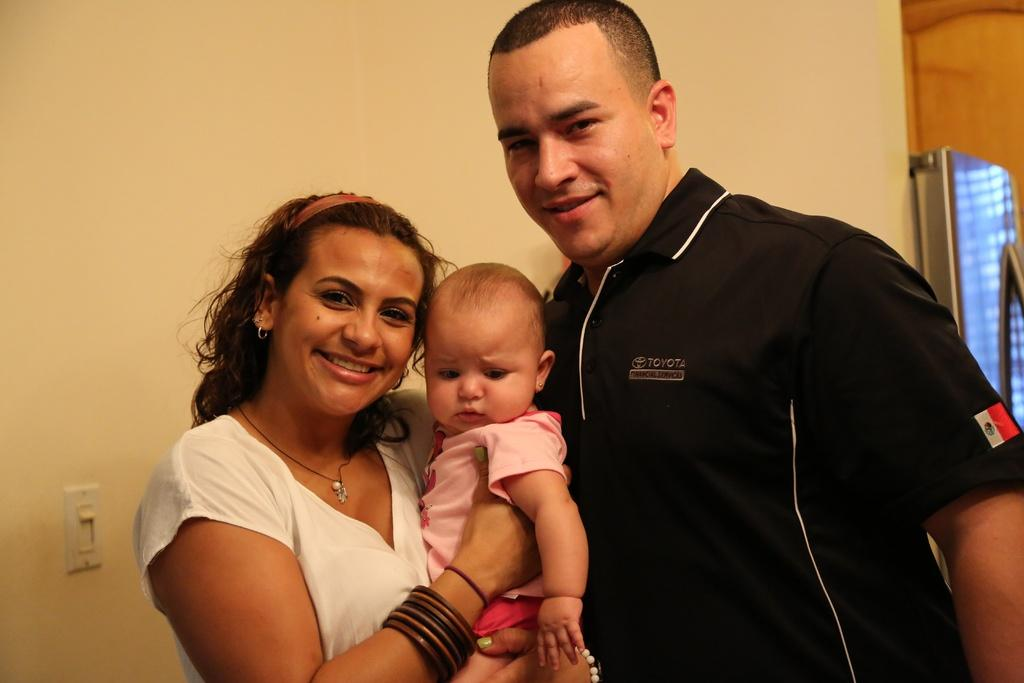<image>
Give a short and clear explanation of the subsequent image. A man wearing a Toyota shirt stands next to a woman holding a baby. 